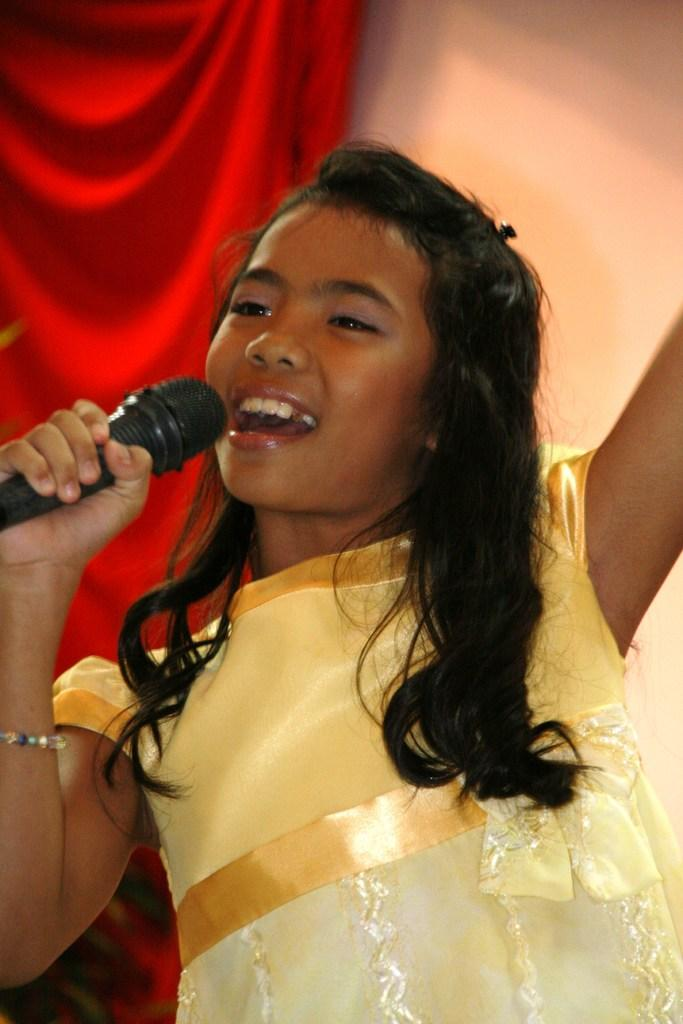Who is the main subject in the image? There is a girl in the image. What is the girl wearing? The girl is wearing a yellow frock. Can you describe the girl's hair? The girl has long hair. What is the girl doing in the image? The girl is singing. What is the girl holding in her right hand? The girl is holding a microphone in her right hand. What can be seen in the background of the image? There is a red cloth and a wall in the background. How many fangs does the girl have in the image? There are no fangs visible in the image, as the girl is not depicted as a creature with fangs. 